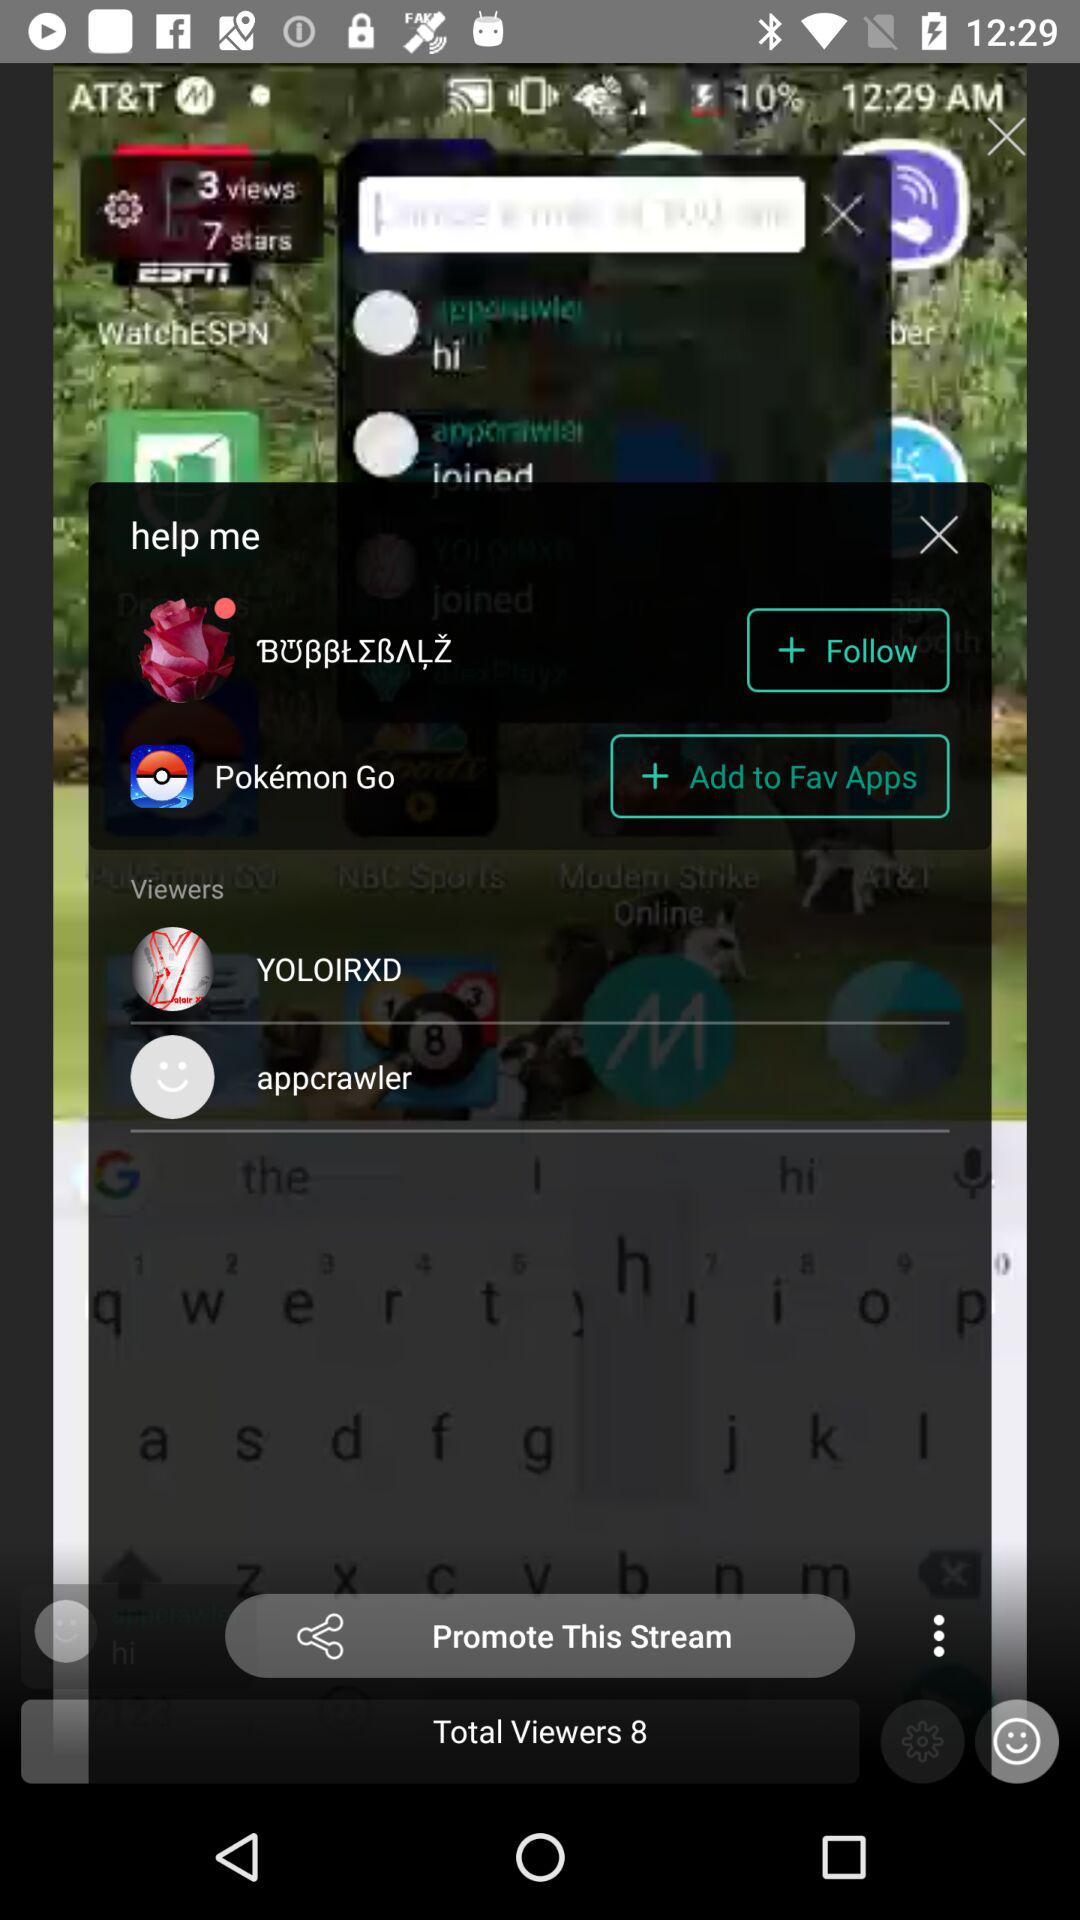What is the name of the user?
When the provided information is insufficient, respond with <no answer>. <no answer> 